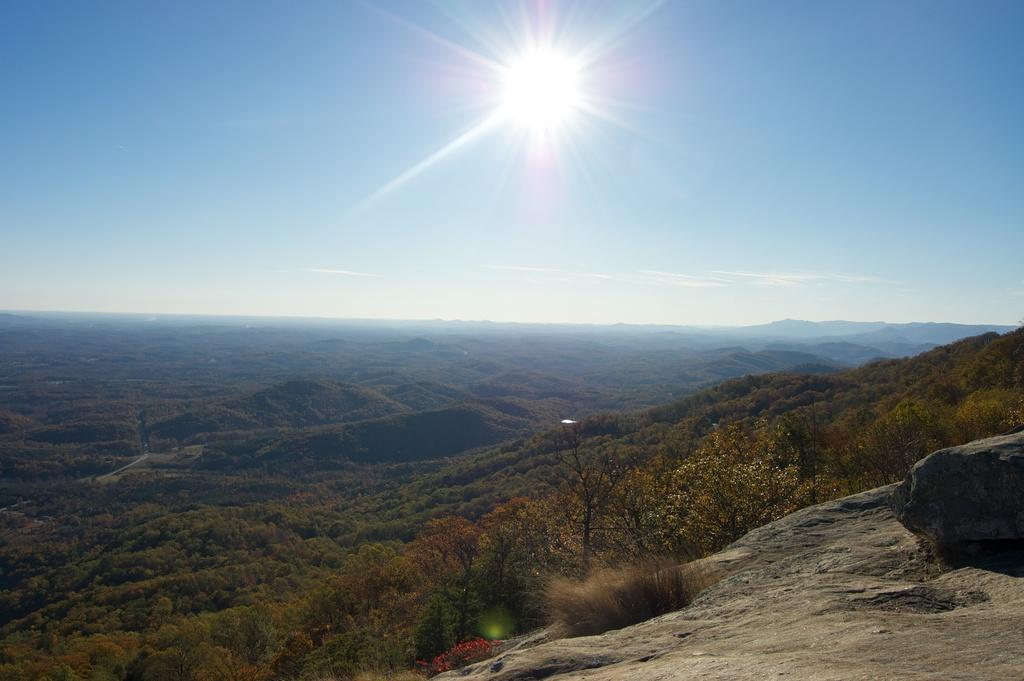What type of vegetation can be seen in the image? There is a group of plants and trees in the image. What natural features are visible in the background of the image? There are mountains in the image. What is the source of light in the sky? The sun is visible in the sky. Can you see the reflection of the sea in the image? There is no sea present in the image, so it is not possible to see its reflection. 